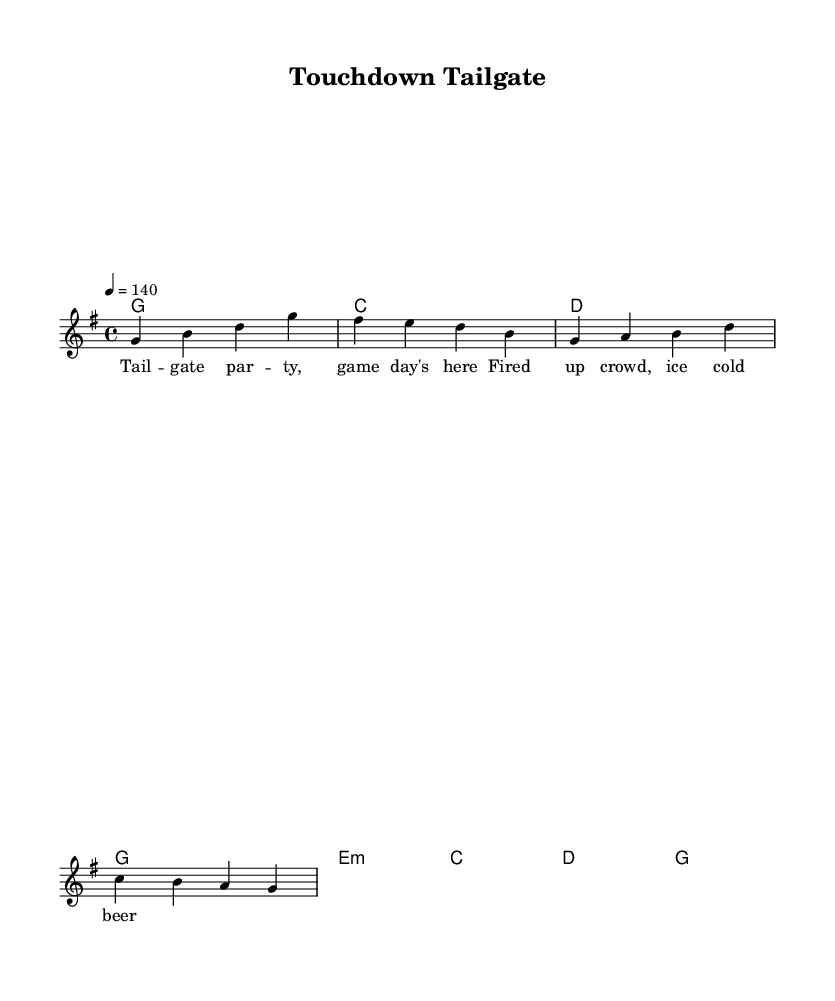What is the key signature of this music? The key signature is G major, which has one sharp (F#).
Answer: G major What is the time signature of this music? The time signature indicates that there are four beats per measure, as shown by "4/4" at the beginning.
Answer: 4/4 What is the tempo of this piece? The tempo is set at 140 beats per minute, specified by "4 = 140".
Answer: 140 How many measures are there in the melody section? The melody consists of four measures as indicated by the grouping of notes.
Answer: 4 What is the first chord in the harmony? The first chord is G major, as denoted by the chord name "g1" at the start.
Answer: G major What genre does this song belong to? The song is in the Country Rock genre, characterized by its energetic feel suitable for tailgating and stadium excitement.
Answer: Country Rock Which lyrical theme is presented in the verse? The verse highlights a tailgate party atmosphere, mentioning a fired-up crowd and cold beer, which are common themes in tailgating culture.
Answer: Tailgate party 